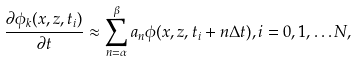<formula> <loc_0><loc_0><loc_500><loc_500>\frac { \partial \phi _ { k } ( x , z , t _ { i } ) } { \partial t } \approx \sum _ { n = \alpha } ^ { \beta } a _ { n } \phi ( x , z , t _ { i } + n \Delta t ) , i = 0 , 1 , \dots N ,</formula> 